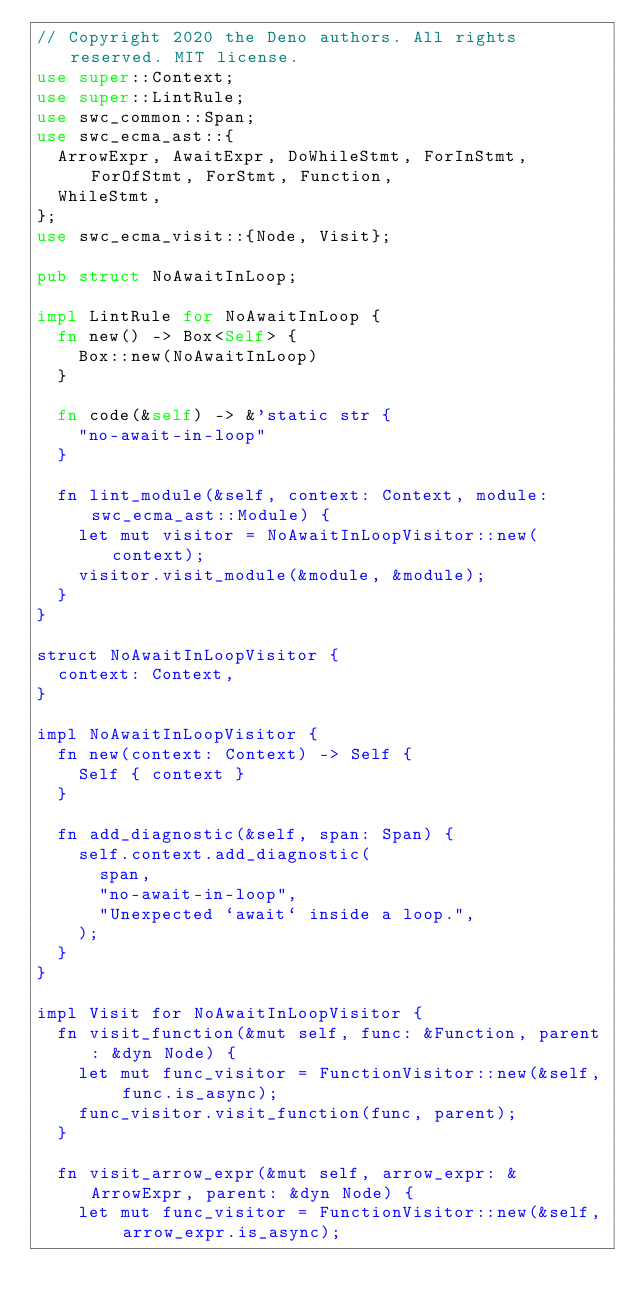Convert code to text. <code><loc_0><loc_0><loc_500><loc_500><_Rust_>// Copyright 2020 the Deno authors. All rights reserved. MIT license.
use super::Context;
use super::LintRule;
use swc_common::Span;
use swc_ecma_ast::{
  ArrowExpr, AwaitExpr, DoWhileStmt, ForInStmt, ForOfStmt, ForStmt, Function,
  WhileStmt,
};
use swc_ecma_visit::{Node, Visit};

pub struct NoAwaitInLoop;

impl LintRule for NoAwaitInLoop {
  fn new() -> Box<Self> {
    Box::new(NoAwaitInLoop)
  }

  fn code(&self) -> &'static str {
    "no-await-in-loop"
  }

  fn lint_module(&self, context: Context, module: swc_ecma_ast::Module) {
    let mut visitor = NoAwaitInLoopVisitor::new(context);
    visitor.visit_module(&module, &module);
  }
}

struct NoAwaitInLoopVisitor {
  context: Context,
}

impl NoAwaitInLoopVisitor {
  fn new(context: Context) -> Self {
    Self { context }
  }

  fn add_diagnostic(&self, span: Span) {
    self.context.add_diagnostic(
      span,
      "no-await-in-loop",
      "Unexpected `await` inside a loop.",
    );
  }
}

impl Visit for NoAwaitInLoopVisitor {
  fn visit_function(&mut self, func: &Function, parent: &dyn Node) {
    let mut func_visitor = FunctionVisitor::new(&self, func.is_async);
    func_visitor.visit_function(func, parent);
  }

  fn visit_arrow_expr(&mut self, arrow_expr: &ArrowExpr, parent: &dyn Node) {
    let mut func_visitor = FunctionVisitor::new(&self, arrow_expr.is_async);</code> 